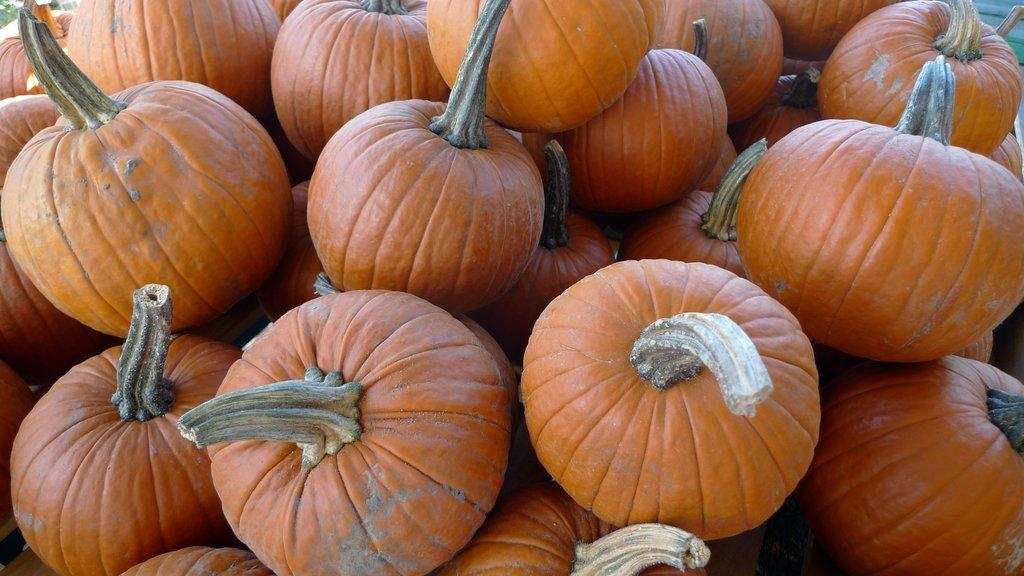What is the primary subject of the image? The primary subject of the image is pumpkins. How many pumpkins are visible in the image? There are many pumpkins in the image. What might be the occasion or season associated with the image? The presence of pumpkins suggests that the image might be related to fall or Halloween. What type of yarn is being used to decorate the side of the pumpkins in the image? There is no yarn or decoration visible on the pumpkins in the image. Where are the pumpkins going on vacation in the image? Pumpkins do not go on vacation, as they are inanimate objects and cannot travel. 